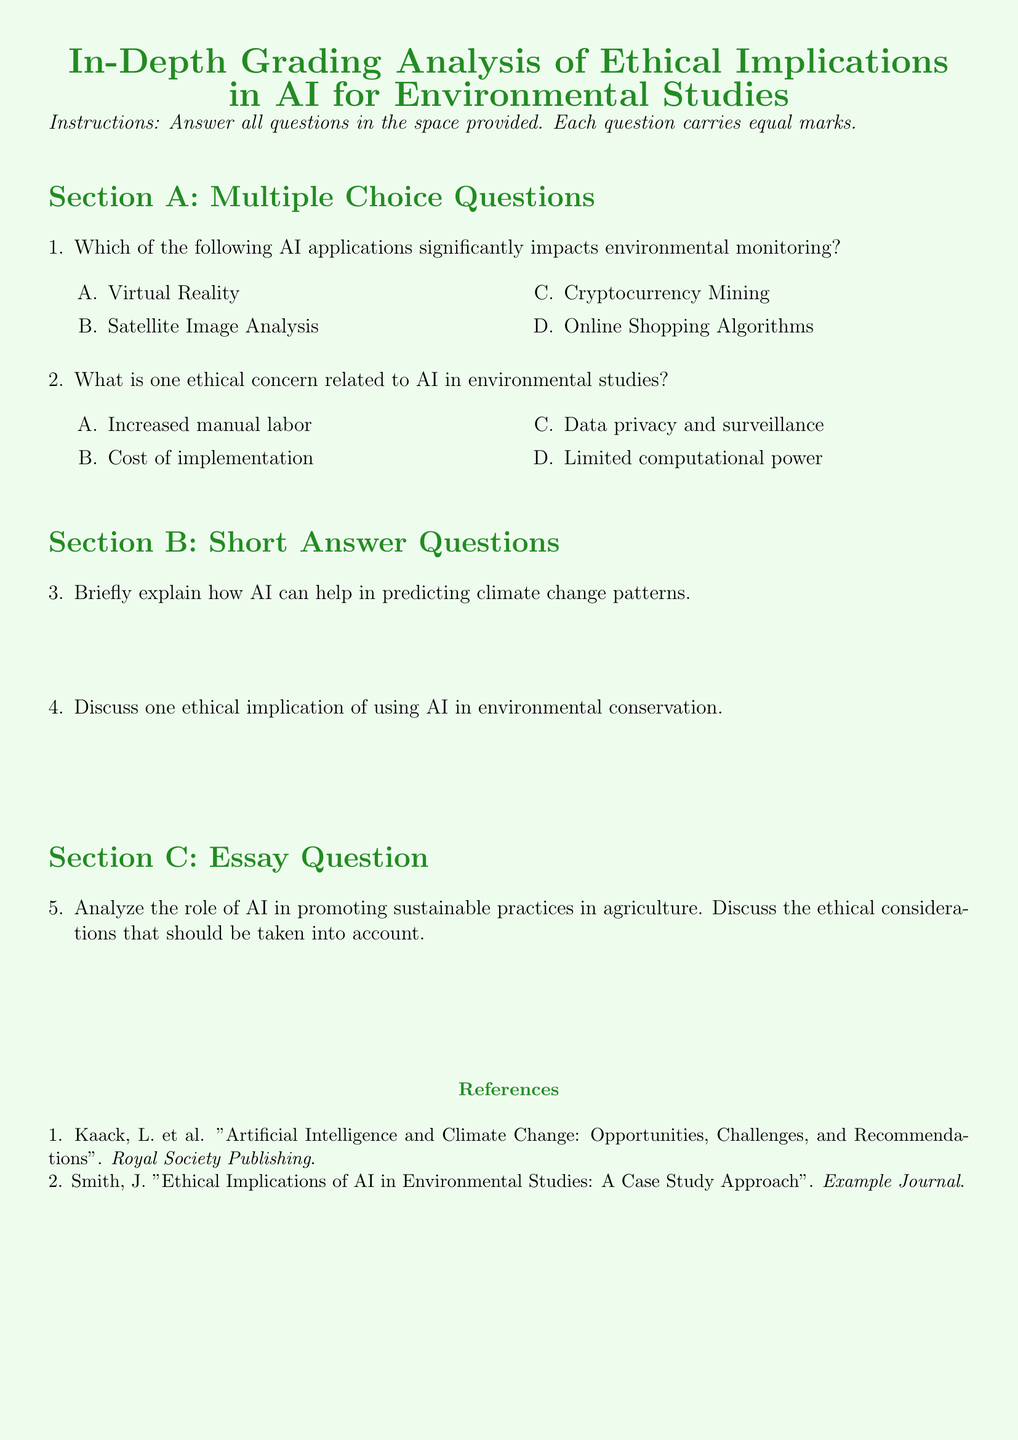What is the title of the document? The title is stated in the title section at the top of the document.
Answer: In-Depth Grading Analysis of Ethical Implications in AI for Environmental Studies How many sections are there in the document? The document includes three main sections as indicated in the layout.
Answer: Three What color is used for the section titles? The color of the section titles is specified in the document formatting.
Answer: Forest green What type of questions are included in Section A? The document specifies the types of questions in each section; Section A is defined as multiple choice questions.
Answer: Multiple Choice Name one ethical concern related to AI in environmental studies listed in Section A. The ethical concerns related to AI in environmental studies are explicitly enumerated in the multiple-choice format.
Answer: Data privacy and surveillance In Section B, what is the second question asking about? The second question in Section B directly states the topic of discussion to be about the ethical implications of AI.
Answer: One ethical implication of using AI in environmental conservation How many sources are listed in the references? The document explicitly lists the items in the references section.
Answer: Two 